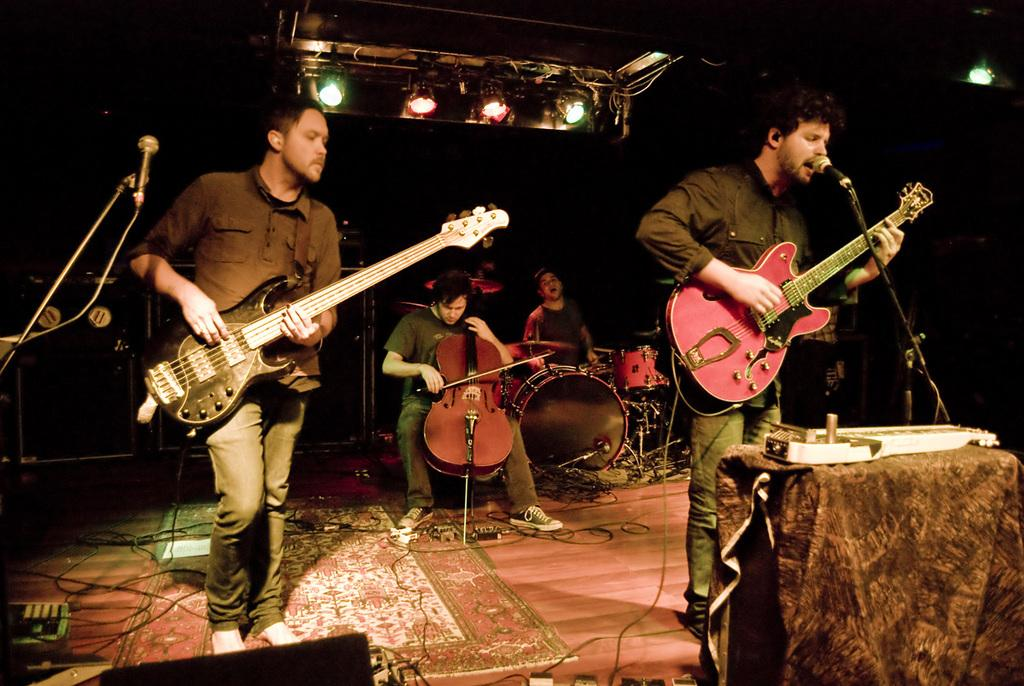What can be seen in the image that provides illumination? There are lights in the image. What objects are present in the image that are used for amplifying sound? There are microphones in the image. What connects the various objects in the image? There are wires in the image. What are the people in the image doing? There are people playing musical instruments in the image. What type of flooring is visible in the image? There is a wooden floor in the image. What is the purpose of the mat in the image? The mat in the image might be used for standing or sitting while playing the musical instruments. What piece of furniture can be seen in the image? There is a table in the image. What type of bubble is floating above the table in the image? There is no bubble present in the image. How do the people playing musical instruments achieve harmony in the image? The image does not provide information about the musical performance or the harmony achieved by the musicians. 